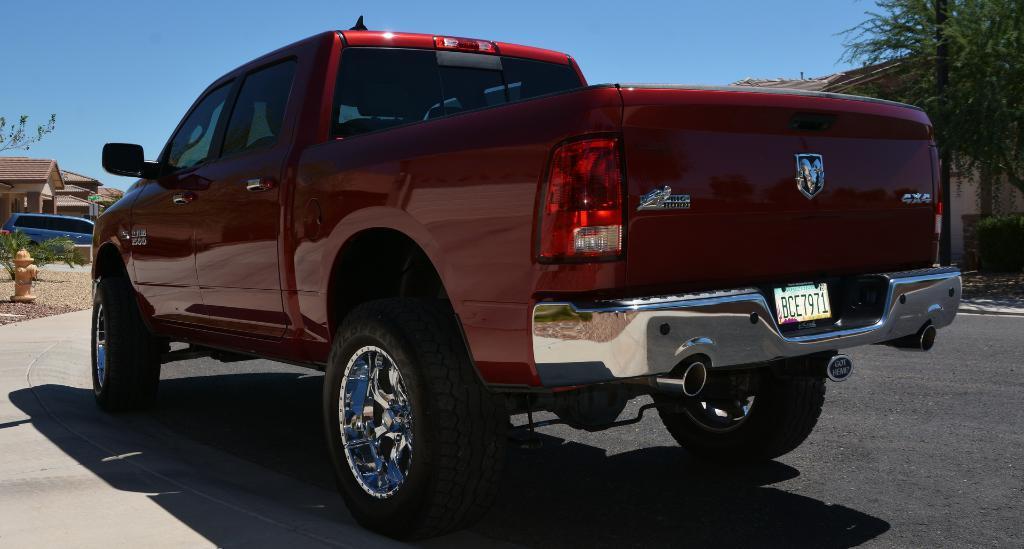How would you summarize this image in a sentence or two? In the image I can see a vehicle on the road and around there are some houses, trees and a fire hydrant to the side. 